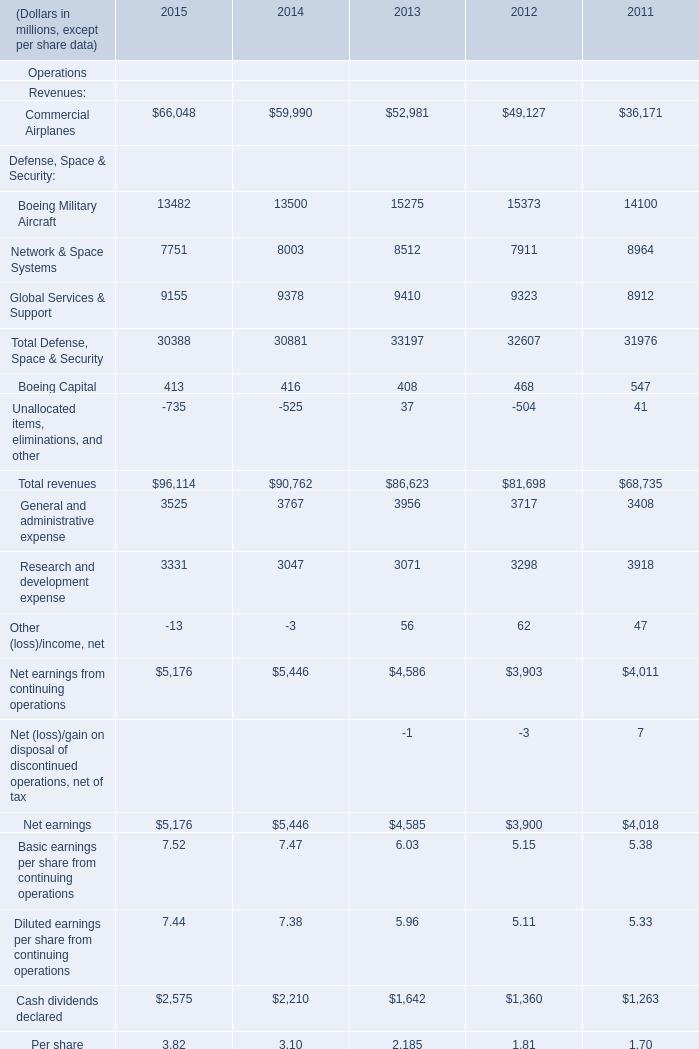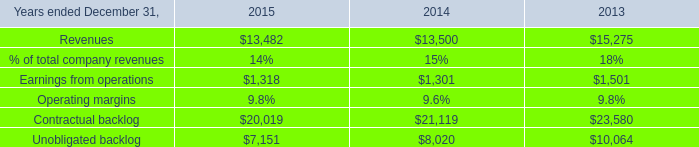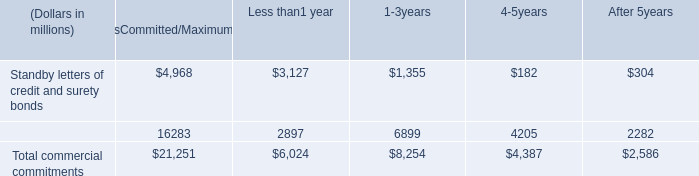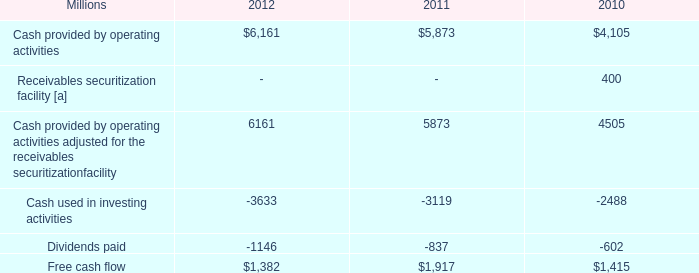In what year is Global Services & Support greater than 9400? 
Answer: 2013. 